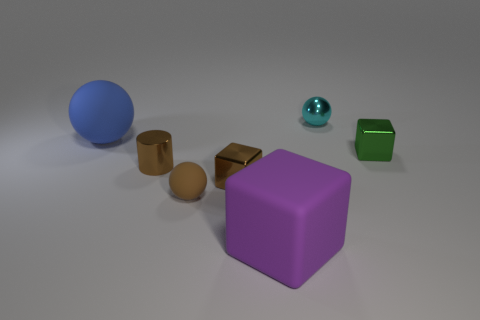Add 3 big yellow matte cubes. How many objects exist? 10 Subtract all cubes. How many objects are left? 4 Subtract all brown matte spheres. Subtract all matte balls. How many objects are left? 4 Add 2 metal objects. How many metal objects are left? 6 Add 4 large blue matte cylinders. How many large blue matte cylinders exist? 4 Subtract 0 red cylinders. How many objects are left? 7 